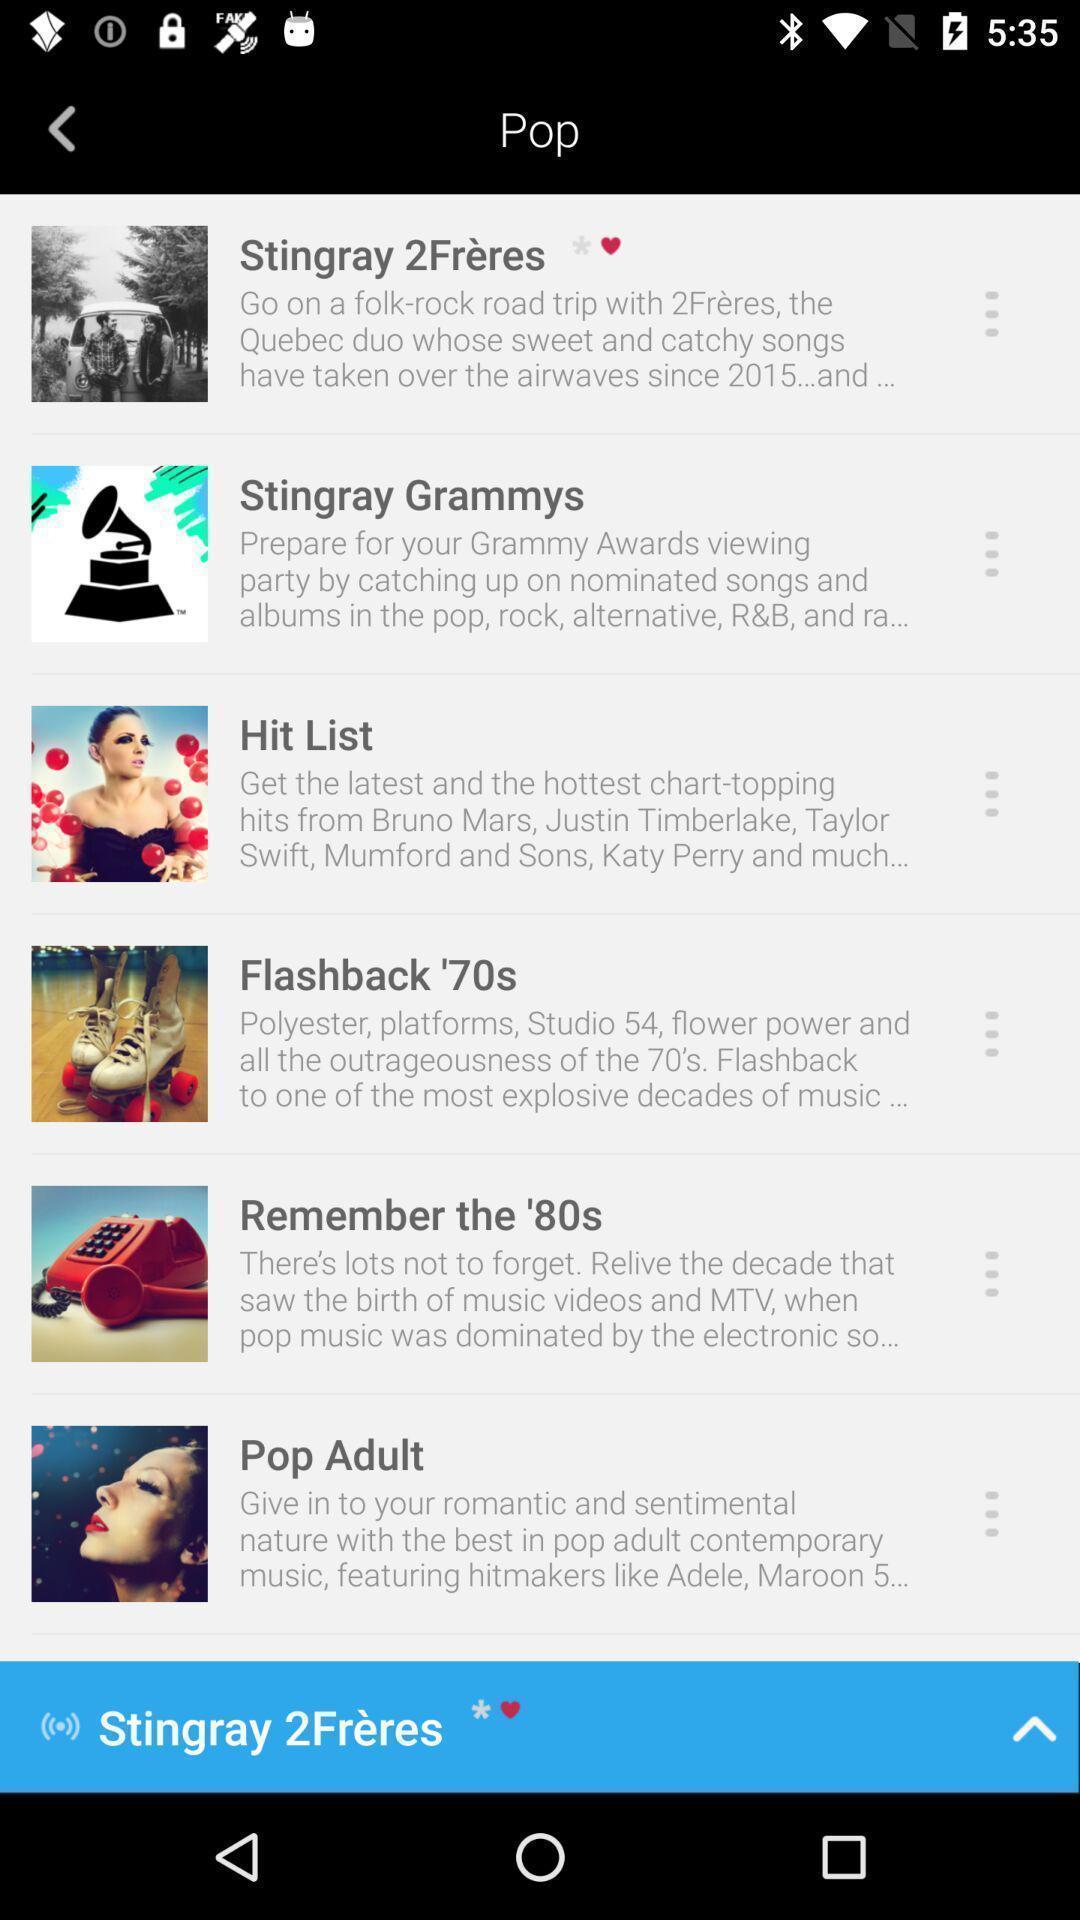Summarize the information in this screenshot. Page displaying list of songs in music app. 